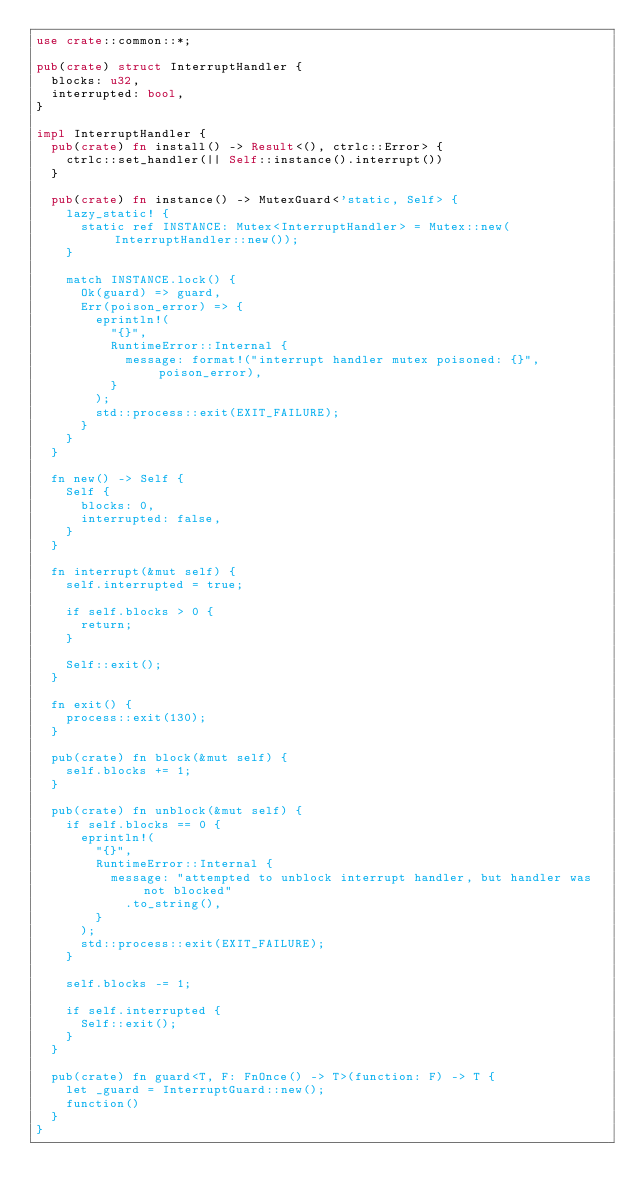Convert code to text. <code><loc_0><loc_0><loc_500><loc_500><_Rust_>use crate::common::*;

pub(crate) struct InterruptHandler {
  blocks: u32,
  interrupted: bool,
}

impl InterruptHandler {
  pub(crate) fn install() -> Result<(), ctrlc::Error> {
    ctrlc::set_handler(|| Self::instance().interrupt())
  }

  pub(crate) fn instance() -> MutexGuard<'static, Self> {
    lazy_static! {
      static ref INSTANCE: Mutex<InterruptHandler> = Mutex::new(InterruptHandler::new());
    }

    match INSTANCE.lock() {
      Ok(guard) => guard,
      Err(poison_error) => {
        eprintln!(
          "{}",
          RuntimeError::Internal {
            message: format!("interrupt handler mutex poisoned: {}", poison_error),
          }
        );
        std::process::exit(EXIT_FAILURE);
      }
    }
  }

  fn new() -> Self {
    Self {
      blocks: 0,
      interrupted: false,
    }
  }

  fn interrupt(&mut self) {
    self.interrupted = true;

    if self.blocks > 0 {
      return;
    }

    Self::exit();
  }

  fn exit() {
    process::exit(130);
  }

  pub(crate) fn block(&mut self) {
    self.blocks += 1;
  }

  pub(crate) fn unblock(&mut self) {
    if self.blocks == 0 {
      eprintln!(
        "{}",
        RuntimeError::Internal {
          message: "attempted to unblock interrupt handler, but handler was not blocked"
            .to_string(),
        }
      );
      std::process::exit(EXIT_FAILURE);
    }

    self.blocks -= 1;

    if self.interrupted {
      Self::exit();
    }
  }

  pub(crate) fn guard<T, F: FnOnce() -> T>(function: F) -> T {
    let _guard = InterruptGuard::new();
    function()
  }
}
</code> 